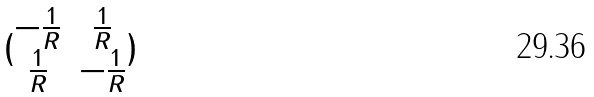Convert formula to latex. <formula><loc_0><loc_0><loc_500><loc_500>( \begin{matrix} - \frac { 1 } { R } & \frac { 1 } { R } \\ \frac { 1 } { R } & - \frac { 1 } { R } \end{matrix} )</formula> 